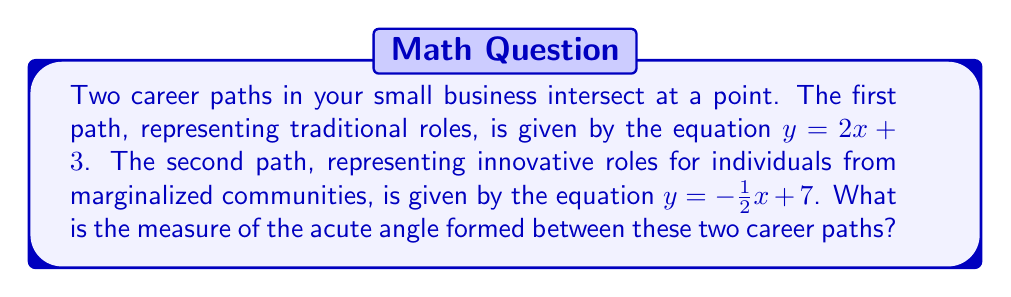Teach me how to tackle this problem. To find the angle between two intersecting lines, we can use the formula:

$$ \tan \theta = \left|\frac{m_1 - m_2}{1 + m_1m_2}\right| $$

Where $m_1$ and $m_2$ are the slopes of the two lines.

Step 1: Identify the slopes
- For $y = 2x + 3$, $m_1 = 2$
- For $y = -\frac{1}{2}x + 7$, $m_2 = -\frac{1}{2}$

Step 2: Substitute into the formula
$$ \tan \theta = \left|\frac{2 - (-\frac{1}{2})}{1 + 2(-\frac{1}{2})}\right| = \left|\frac{2 + \frac{1}{2}}{1 - 1}\right| = \left|\frac{\frac{5}{2}}{0}\right| $$

Step 3: Simplify
$$ \tan \theta = \frac{5}{2} = 2.5 $$

Step 4: Find the angle using inverse tangent
$$ \theta = \tan^{-1}(2.5) \approx 68.20° $$

Therefore, the acute angle between the two career paths is approximately 68.20°.
Answer: $68.20°$ 